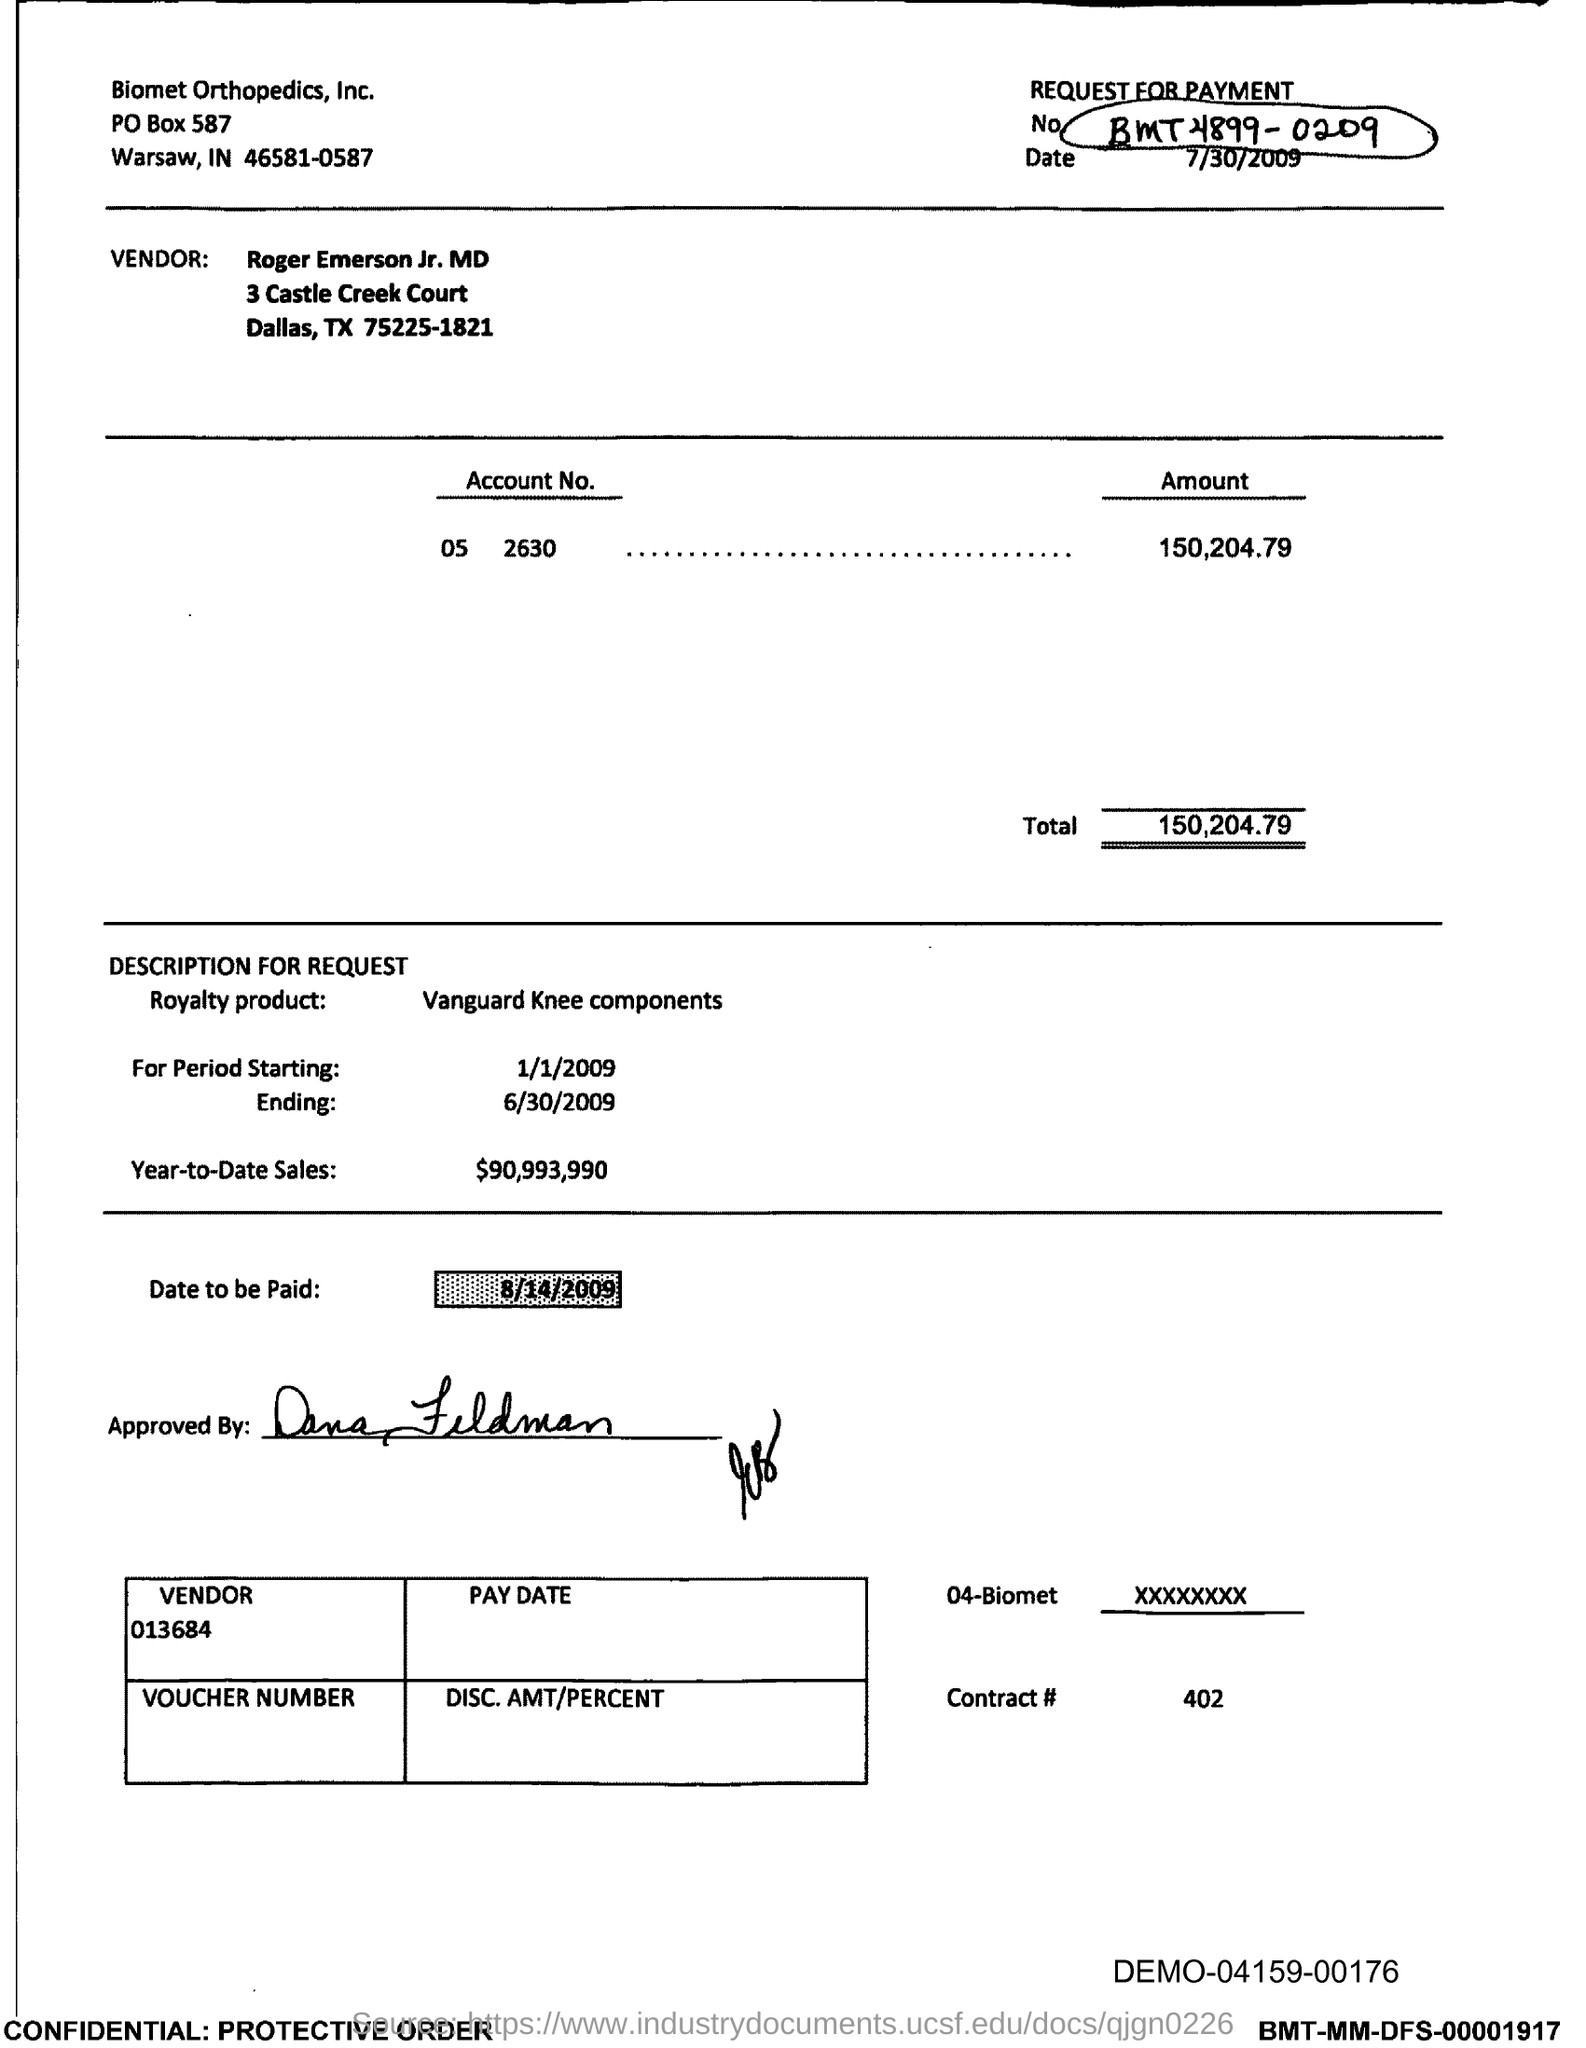Mention a couple of crucial points in this snapshot. Vanguard Knee components are the name of a royalty-based product. What is the date to be paid? August 14th, 2009. As of the end of the current reporting period, the year-to-date sales amounted to $90,993,990. The address of Biomet Orthopedics, Inc. is P.O. Box No. 587. Biomet Orthopedic, Inc is located in the state of Indiana. 